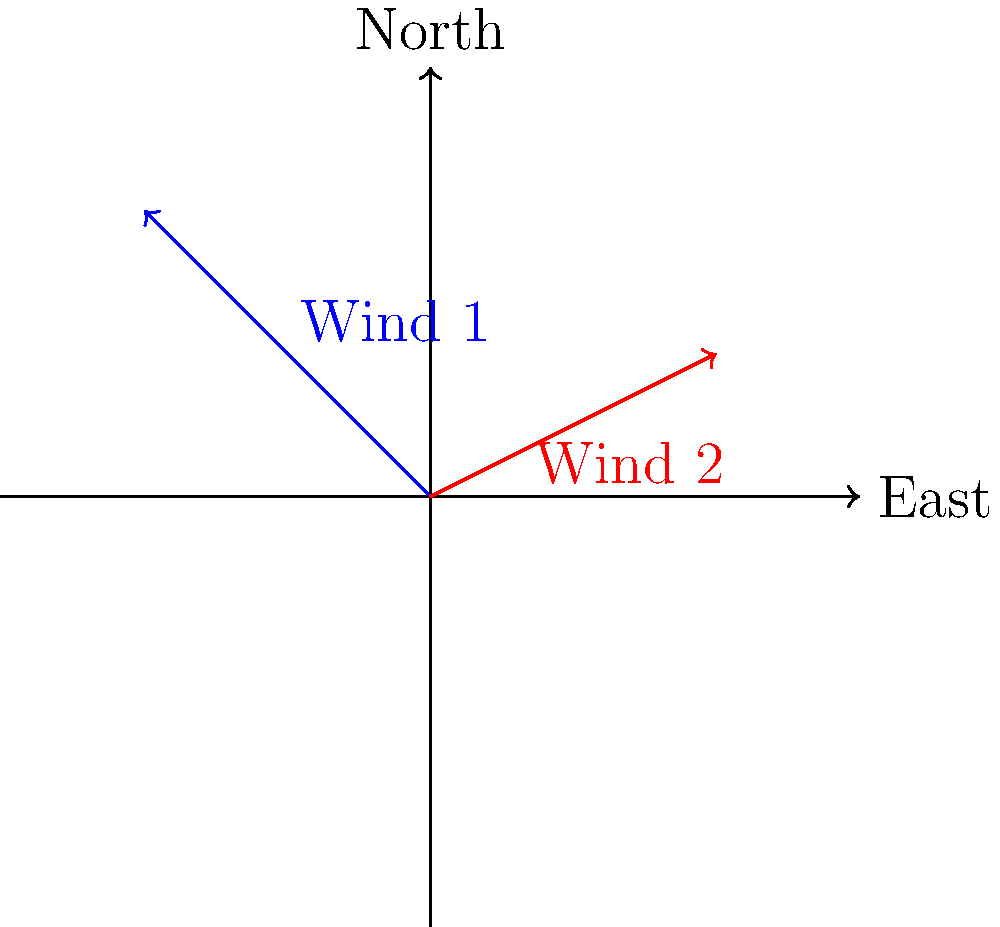Look at the picture showing wind directions. The blue arrow (Wind 1) shows wind blowing towards the crops at 20 km/h. The red arrow (Wind 2) shows wind blowing at 15 km/h. If both winds blow at the same time, in which direction will the crops bend? Will they bend more towards the North or East? Let's break this down step-by-step:

1. We need to add these two wind vectors together.

2. Wind 1 (blue arrow):
   - Blowing towards Northeast
   - Speed: 20 km/h
   - We can split this into North and East components:
     North component = $20 \times \frac{\sqrt{2}}{2} = 10\sqrt{2}$ km/h
     East component = $20 \times \frac{\sqrt{2}}{2} = 10\sqrt{2}$ km/h

3. Wind 2 (red arrow):
   - Blowing towards East-Northeast
   - Speed: 15 km/h
   - We can split this into North and East components:
     North component = $15 \times \frac{1}{2} = 7.5$ km/h
     East component = $15 \times \frac{\sqrt{3}}{2} \approx 13$ km/h

4. Now, we add the components:
   Total North component = $10\sqrt{2} + 7.5 \approx 21.6$ km/h
   Total East component = $10\sqrt{2} + 13 \approx 27.1$ km/h

5. The combined wind will blow in a direction between North and East, but more towards East because the East component (27.1 km/h) is stronger than the North component (21.6 km/h).

Therefore, the crops will bend towards the Northeast, but more towards the East than the North.
Answer: Northeast, more towards East 